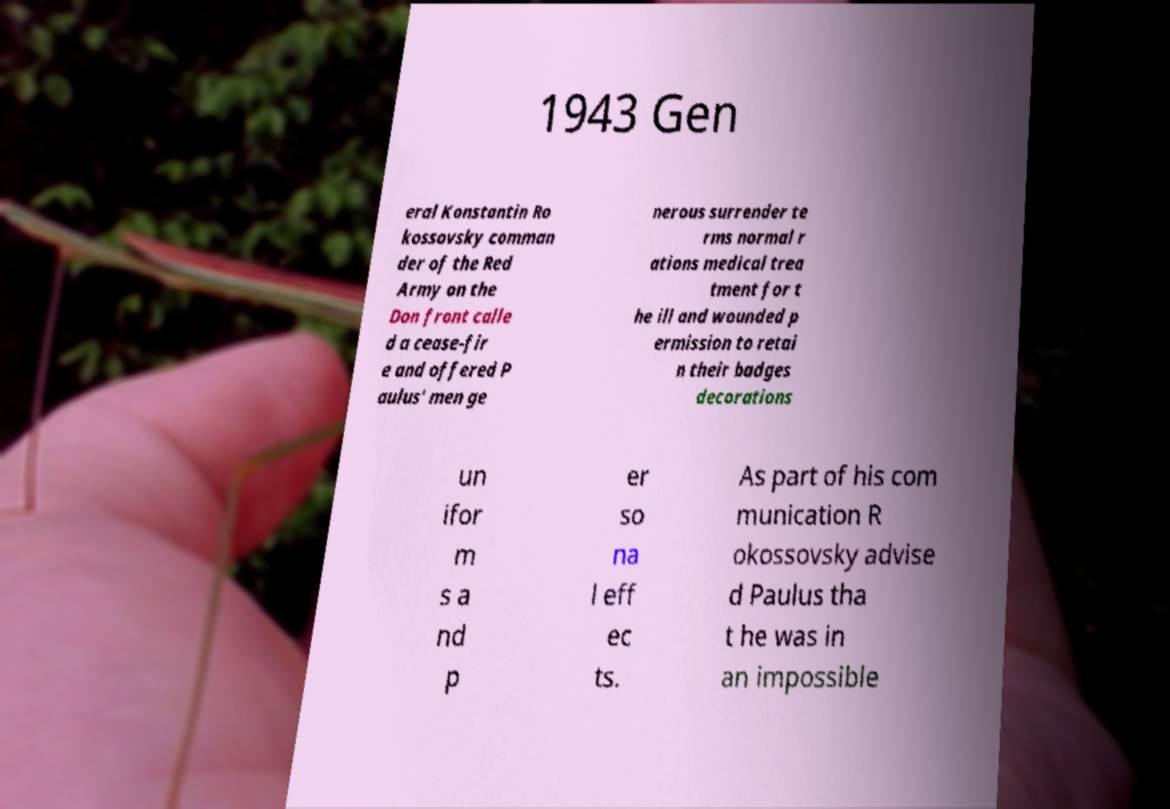Please identify and transcribe the text found in this image. 1943 Gen eral Konstantin Ro kossovsky comman der of the Red Army on the Don front calle d a cease-fir e and offered P aulus' men ge nerous surrender te rms normal r ations medical trea tment for t he ill and wounded p ermission to retai n their badges decorations un ifor m s a nd p er so na l eff ec ts. As part of his com munication R okossovsky advise d Paulus tha t he was in an impossible 